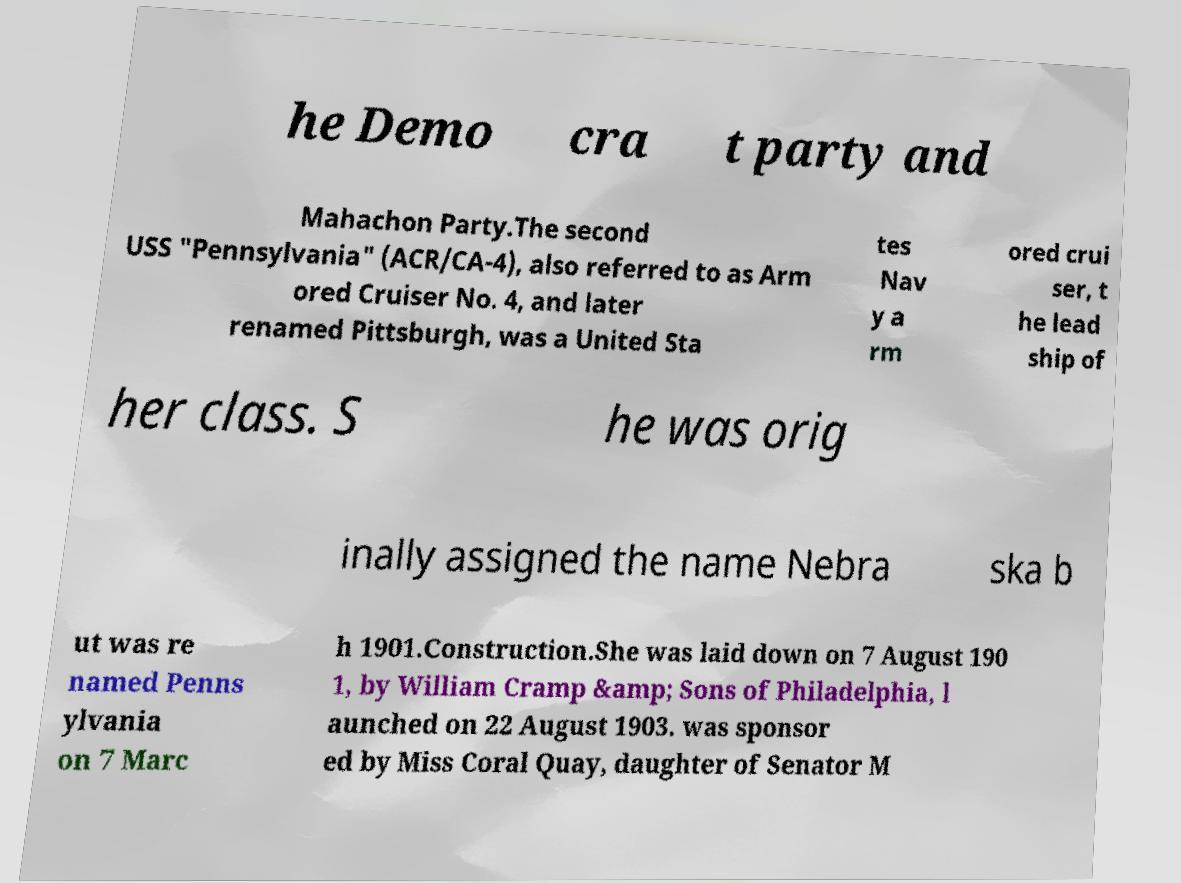What messages or text are displayed in this image? I need them in a readable, typed format. he Demo cra t party and Mahachon Party.The second USS "Pennsylvania" (ACR/CA-4), also referred to as Arm ored Cruiser No. 4, and later renamed Pittsburgh, was a United Sta tes Nav y a rm ored crui ser, t he lead ship of her class. S he was orig inally assigned the name Nebra ska b ut was re named Penns ylvania on 7 Marc h 1901.Construction.She was laid down on 7 August 190 1, by William Cramp &amp; Sons of Philadelphia, l aunched on 22 August 1903. was sponsor ed by Miss Coral Quay, daughter of Senator M 